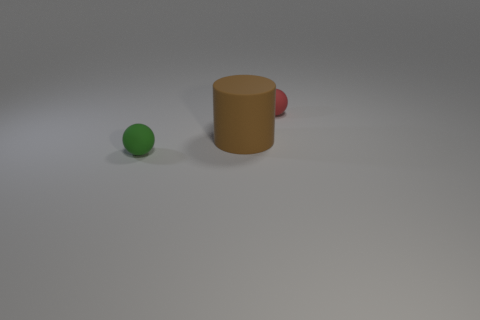Add 2 green spheres. How many objects exist? 5 Subtract all cylinders. How many objects are left? 2 Subtract all purple blocks. How many cyan cylinders are left? 0 Subtract all red spheres. Subtract all green matte balls. How many objects are left? 1 Add 1 large matte cylinders. How many large matte cylinders are left? 2 Add 1 big red spheres. How many big red spheres exist? 1 Subtract all red spheres. How many spheres are left? 1 Subtract 1 green spheres. How many objects are left? 2 Subtract 1 spheres. How many spheres are left? 1 Subtract all blue balls. Subtract all purple blocks. How many balls are left? 2 